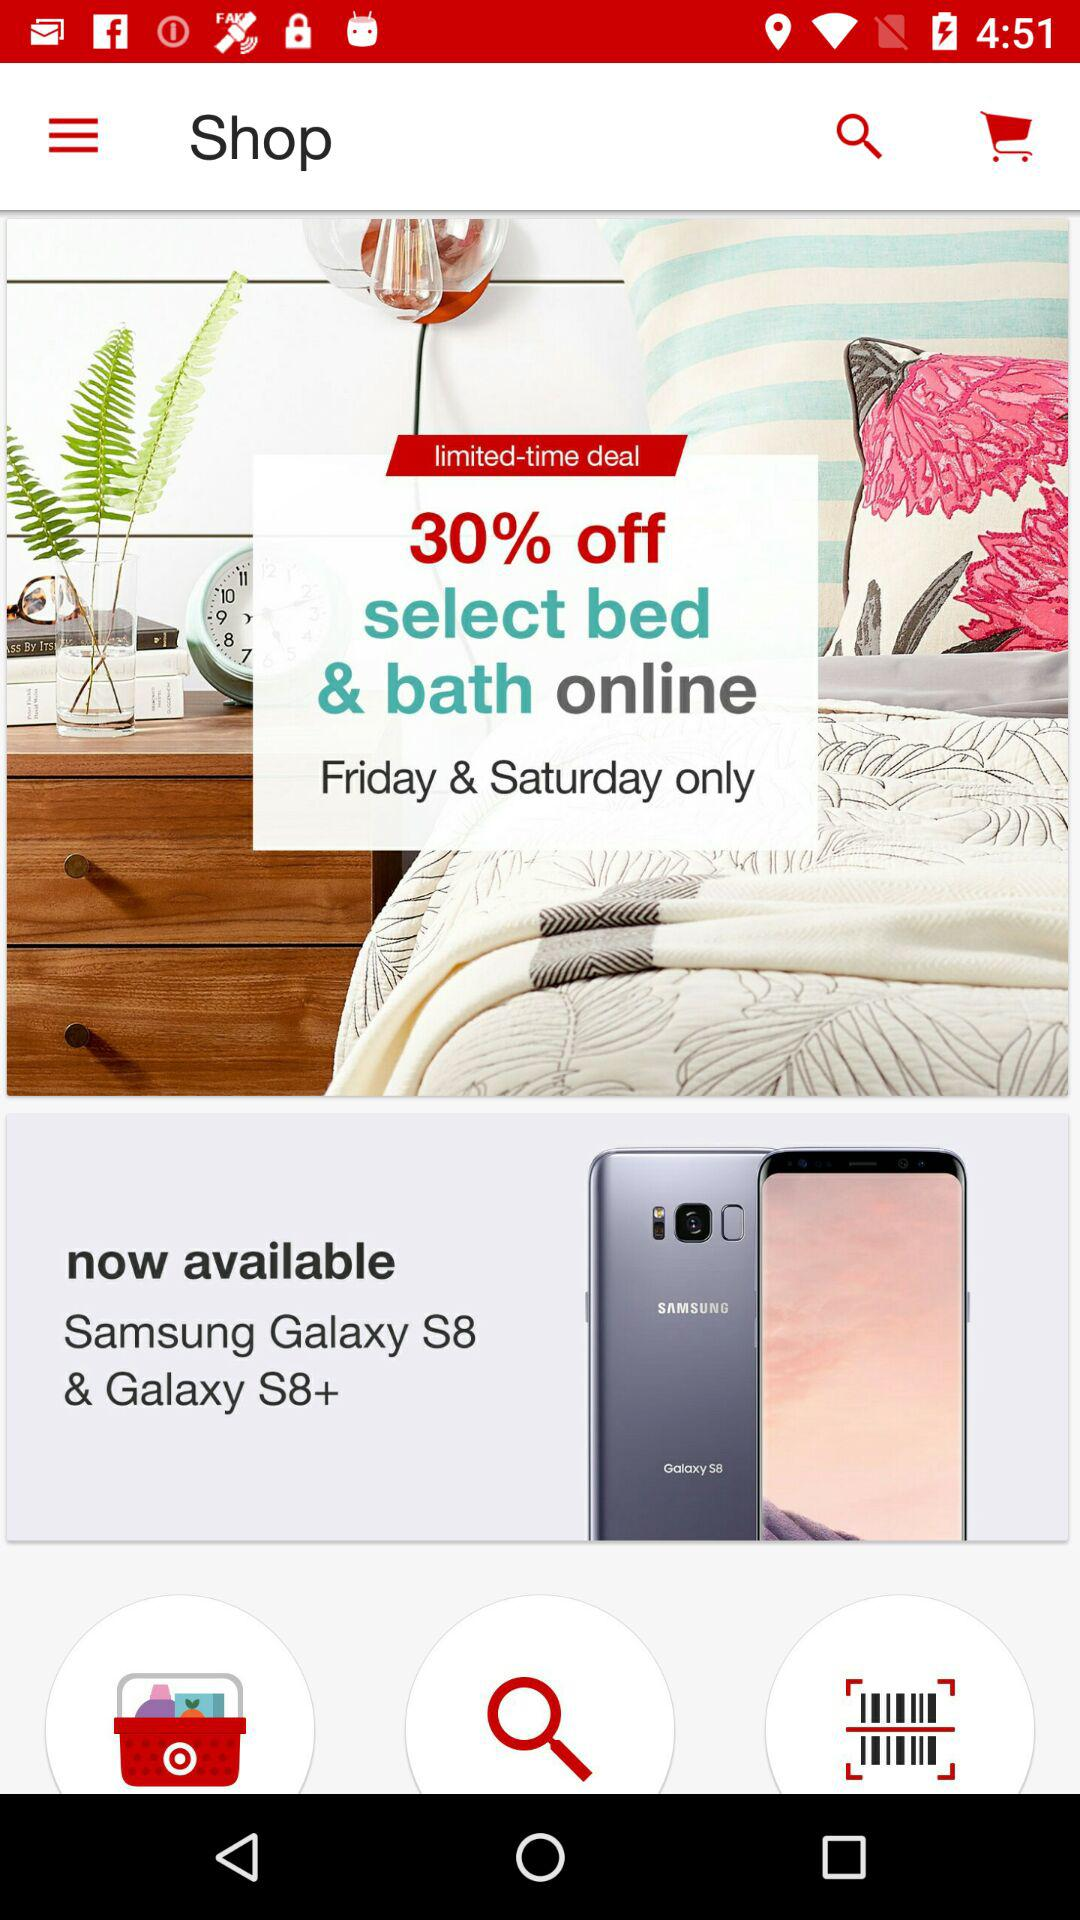What models of phones are available? The phone models available are "Samsung Galaxy S8 & Galaxy S8+". 